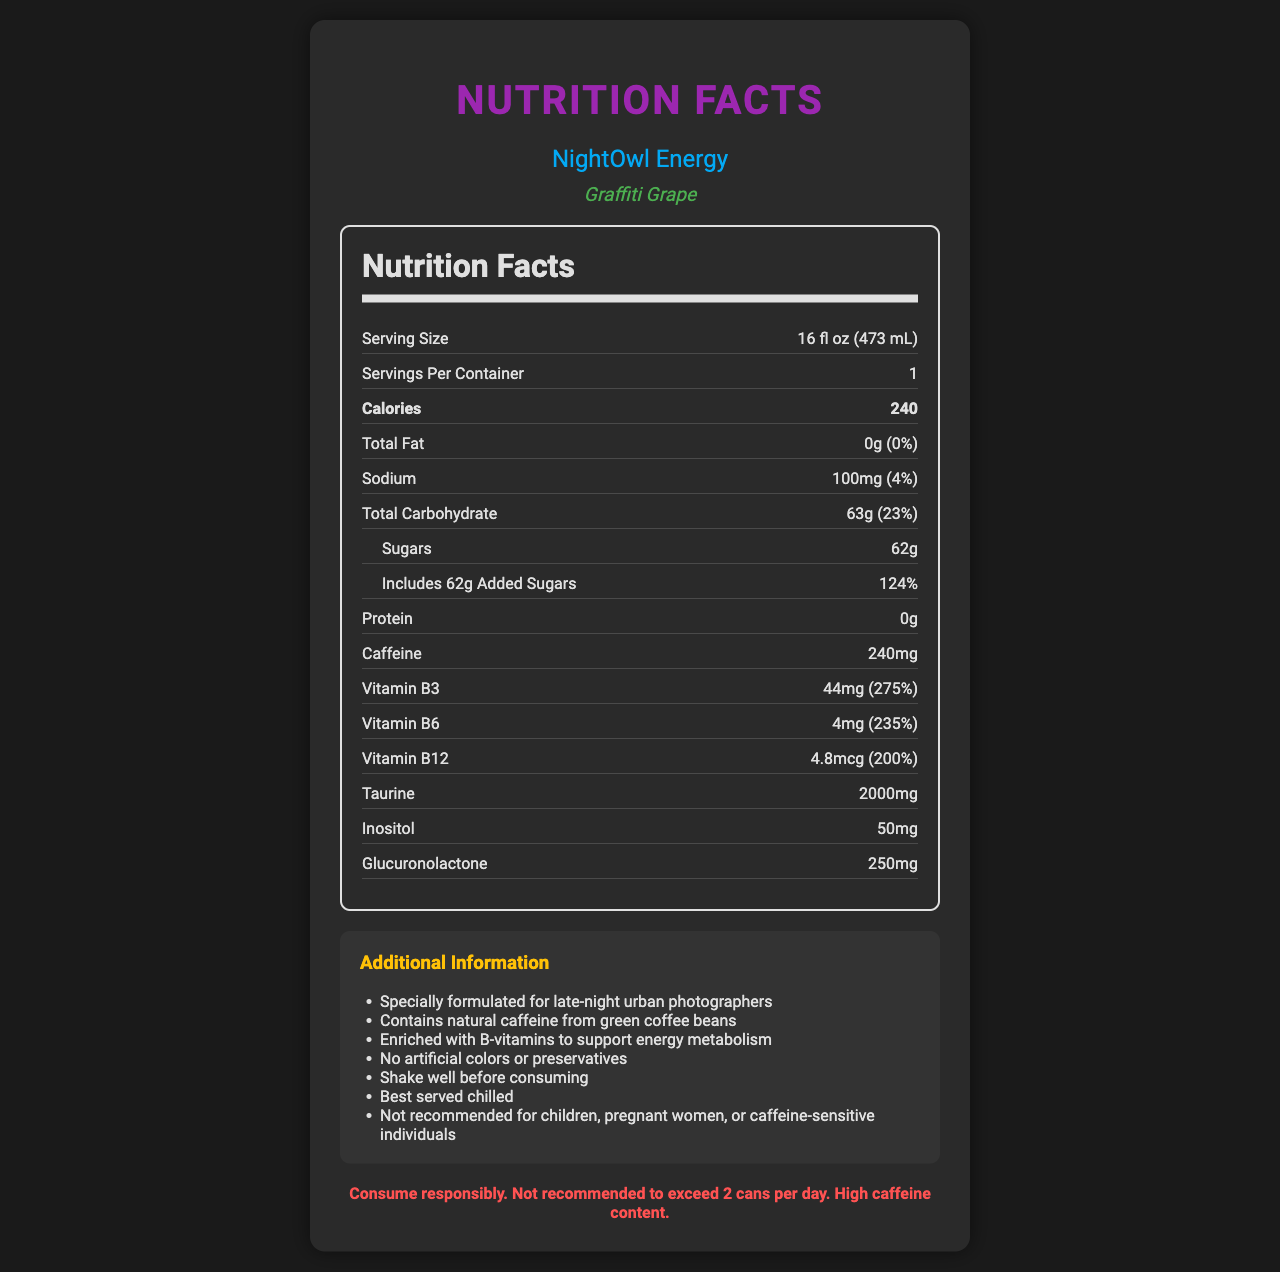what is the serving size? The serving size is explicitly mentioned at the top of the nutrition facts section.
Answer: 16 fl oz (473 mL) how many calories are in one serving? The calorie content is prominently displayed in bold within the nutrition facts section.
Answer: 240 what is the daily value percentage of sodium in this energy drink? Within the nutrition facts, next to the sodium amount (100mg), the daily value percentage is listed as 4%.
Answer: 4% how much sugar does this energy drink contain? The amount of sugar is listed under the total carbohydrate section as 62g.
Answer: 62g how much caffeine is in one serving of this energy drink? The caffeine content is listed separately towards the end of the nutrition facts section.
Answer: 240mg what are the B-vitamins included in this drink? A. B1, B2, B3 B. B6, B12, B9 C. B3, B6, B12 The document lists amounts and daily values for Vitamin B3, B6, and B12 under the nutrition facts.
Answer: C how much taurine is in this drink? A. 1000mg B. 1500mg C. 2000mg D. 2500mg The taurine content is specified as 2000mg within the nutrition facts section.
Answer: C is there any protein in this energy drink? The protein content is explicitly noted as 0g in the document.
Answer: No what is the name of the energy drink brand? The brand name "NightOwl Energy" is displayed at the top of the document, in the "brand" section.
Answer: NightOwl Energy what is the flavor of this energy drink? The flavor name "Graffiti Grape" is displayed immediately under the brand name.
Answer: Graffiti Grape what is the warning statement on this label? The document includes a warning statement placed at the bottom of the document that advises on responsible consumption.
Answer: Consume responsibly. Not recommended to exceed 2 cans per day. High caffeine content. summarize the main idea of the document. The document serves as a detailed description of the nutrition facts and additional product information for the "NightOwl Energy" drink, including caloric content, ingredients, warnings, and special notes for certain demographics.
Answer: The document is a nutrition facts label for NightOwl Energy's Graffiti Grape flavored energy drink. It provides detailed nutritional information including calorie count, vitamin content, and caffeine levels, along with a consumption warning. what is the production date of this energy drink? The document does not provide any information about the production date of the energy drink.
Answer: Cannot be determined 